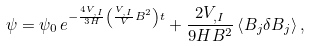Convert formula to latex. <formula><loc_0><loc_0><loc_500><loc_500>\psi = \psi _ { 0 } \, e ^ { - \frac { 4 V _ { , I } } { 3 H } \left ( \frac { V _ { , I } } { V } B ^ { 2 } \right ) t } + \frac { 2 V _ { , I } } { 9 H B ^ { 2 } } \left \langle B _ { j } \delta B _ { j } \right \rangle ,</formula> 